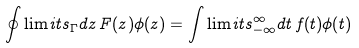Convert formula to latex. <formula><loc_0><loc_0><loc_500><loc_500>\oint \lim i t s _ { \Gamma } d z \, F ( z ) \phi ( z ) = \int \lim i t s _ { - \infty } ^ { \infty } d t \, f ( t ) \phi ( t )</formula> 